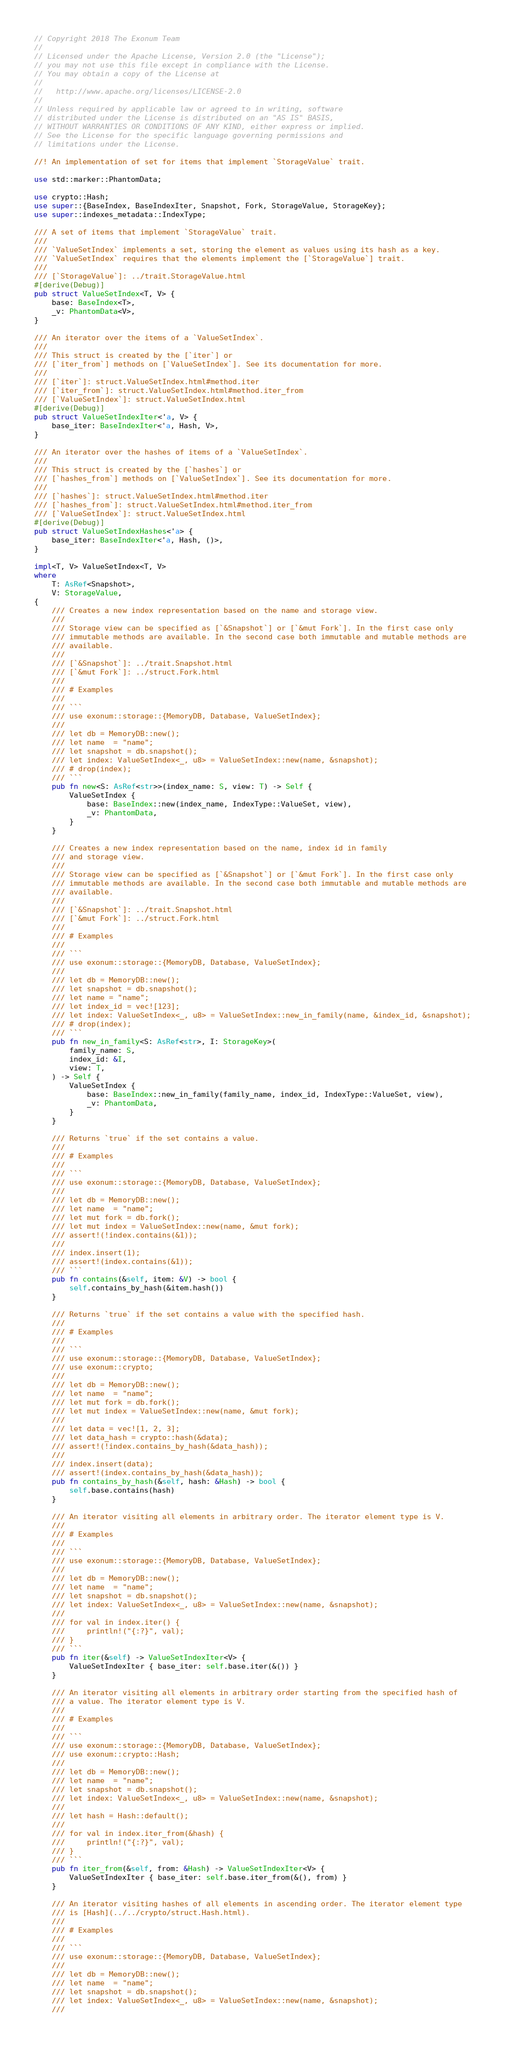<code> <loc_0><loc_0><loc_500><loc_500><_Rust_>// Copyright 2018 The Exonum Team
//
// Licensed under the Apache License, Version 2.0 (the "License");
// you may not use this file except in compliance with the License.
// You may obtain a copy of the License at
//
//   http://www.apache.org/licenses/LICENSE-2.0
//
// Unless required by applicable law or agreed to in writing, software
// distributed under the License is distributed on an "AS IS" BASIS,
// WITHOUT WARRANTIES OR CONDITIONS OF ANY KIND, either express or implied.
// See the License for the specific language governing permissions and
// limitations under the License.

//! An implementation of set for items that implement `StorageValue` trait.

use std::marker::PhantomData;

use crypto::Hash;
use super::{BaseIndex, BaseIndexIter, Snapshot, Fork, StorageValue, StorageKey};
use super::indexes_metadata::IndexType;

/// A set of items that implement `StorageValue` trait.
///
/// `ValueSetIndex` implements a set, storing the element as values using its hash as a key.
/// `ValueSetIndex` requires that the elements implement the [`StorageValue`] trait.
///
/// [`StorageValue`]: ../trait.StorageValue.html
#[derive(Debug)]
pub struct ValueSetIndex<T, V> {
    base: BaseIndex<T>,
    _v: PhantomData<V>,
}

/// An iterator over the items of a `ValueSetIndex`.
///
/// This struct is created by the [`iter`] or
/// [`iter_from`] methods on [`ValueSetIndex`]. See its documentation for more.
///
/// [`iter`]: struct.ValueSetIndex.html#method.iter
/// [`iter_from`]: struct.ValueSetIndex.html#method.iter_from
/// [`ValueSetIndex`]: struct.ValueSetIndex.html
#[derive(Debug)]
pub struct ValueSetIndexIter<'a, V> {
    base_iter: BaseIndexIter<'a, Hash, V>,
}

/// An iterator over the hashes of items of a `ValueSetIndex`.
///
/// This struct is created by the [`hashes`] or
/// [`hashes_from`] methods on [`ValueSetIndex`]. See its documentation for more.
///
/// [`hashes`]: struct.ValueSetIndex.html#method.iter
/// [`hashes_from`]: struct.ValueSetIndex.html#method.iter_from
/// [`ValueSetIndex`]: struct.ValueSetIndex.html
#[derive(Debug)]
pub struct ValueSetIndexHashes<'a> {
    base_iter: BaseIndexIter<'a, Hash, ()>,
}

impl<T, V> ValueSetIndex<T, V>
where
    T: AsRef<Snapshot>,
    V: StorageValue,
{
    /// Creates a new index representation based on the name and storage view.
    ///
    /// Storage view can be specified as [`&Snapshot`] or [`&mut Fork`]. In the first case only
    /// immutable methods are available. In the second case both immutable and mutable methods are
    /// available.
    ///
    /// [`&Snapshot`]: ../trait.Snapshot.html
    /// [`&mut Fork`]: ../struct.Fork.html
    ///
    /// # Examples
    ///
    /// ```
    /// use exonum::storage::{MemoryDB, Database, ValueSetIndex};
    ///
    /// let db = MemoryDB::new();
    /// let name  = "name";
    /// let snapshot = db.snapshot();
    /// let index: ValueSetIndex<_, u8> = ValueSetIndex::new(name, &snapshot);
    /// # drop(index);
    /// ```
    pub fn new<S: AsRef<str>>(index_name: S, view: T) -> Self {
        ValueSetIndex {
            base: BaseIndex::new(index_name, IndexType::ValueSet, view),
            _v: PhantomData,
        }
    }

    /// Creates a new index representation based on the name, index id in family
    /// and storage view.
    ///
    /// Storage view can be specified as [`&Snapshot`] or [`&mut Fork`]. In the first case only
    /// immutable methods are available. In the second case both immutable and mutable methods are
    /// available.
    ///
    /// [`&Snapshot`]: ../trait.Snapshot.html
    /// [`&mut Fork`]: ../struct.Fork.html
    ///
    /// # Examples
    ///
    /// ```
    /// use exonum::storage::{MemoryDB, Database, ValueSetIndex};
    ///
    /// let db = MemoryDB::new();
    /// let snapshot = db.snapshot();
    /// let name = "name";
    /// let index_id = vec![123];
    /// let index: ValueSetIndex<_, u8> = ValueSetIndex::new_in_family(name, &index_id, &snapshot);
    /// # drop(index);
    /// ```
    pub fn new_in_family<S: AsRef<str>, I: StorageKey>(
        family_name: S,
        index_id: &I,
        view: T,
    ) -> Self {
        ValueSetIndex {
            base: BaseIndex::new_in_family(family_name, index_id, IndexType::ValueSet, view),
            _v: PhantomData,
        }
    }

    /// Returns `true` if the set contains a value.
    ///
    /// # Examples
    ///
    /// ```
    /// use exonum::storage::{MemoryDB, Database, ValueSetIndex};
    ///
    /// let db = MemoryDB::new();
    /// let name  = "name";
    /// let mut fork = db.fork();
    /// let mut index = ValueSetIndex::new(name, &mut fork);
    /// assert!(!index.contains(&1));
    ///
    /// index.insert(1);
    /// assert!(index.contains(&1));
    /// ```
    pub fn contains(&self, item: &V) -> bool {
        self.contains_by_hash(&item.hash())
    }

    /// Returns `true` if the set contains a value with the specified hash.
    ///
    /// # Examples
    ///
    /// ```
    /// use exonum::storage::{MemoryDB, Database, ValueSetIndex};
    /// use exonum::crypto;
    ///
    /// let db = MemoryDB::new();
    /// let name  = "name";
    /// let mut fork = db.fork();
    /// let mut index = ValueSetIndex::new(name, &mut fork);
    ///
    /// let data = vec![1, 2, 3];
    /// let data_hash = crypto::hash(&data);
    /// assert!(!index.contains_by_hash(&data_hash));
    ///
    /// index.insert(data);
    /// assert!(index.contains_by_hash(&data_hash));
    pub fn contains_by_hash(&self, hash: &Hash) -> bool {
        self.base.contains(hash)
    }

    /// An iterator visiting all elements in arbitrary order. The iterator element type is V.
    ///
    /// # Examples
    ///
    /// ```
    /// use exonum::storage::{MemoryDB, Database, ValueSetIndex};
    ///
    /// let db = MemoryDB::new();
    /// let name  = "name";
    /// let snapshot = db.snapshot();
    /// let index: ValueSetIndex<_, u8> = ValueSetIndex::new(name, &snapshot);
    ///
    /// for val in index.iter() {
    ///     println!("{:?}", val);
    /// }
    /// ```
    pub fn iter(&self) -> ValueSetIndexIter<V> {
        ValueSetIndexIter { base_iter: self.base.iter(&()) }
    }

    /// An iterator visiting all elements in arbitrary order starting from the specified hash of
    /// a value. The iterator element type is V.
    ///
    /// # Examples
    ///
    /// ```
    /// use exonum::storage::{MemoryDB, Database, ValueSetIndex};
    /// use exonum::crypto::Hash;
    ///
    /// let db = MemoryDB::new();
    /// let name  = "name";
    /// let snapshot = db.snapshot();
    /// let index: ValueSetIndex<_, u8> = ValueSetIndex::new(name, &snapshot);
    ///
    /// let hash = Hash::default();
    ///
    /// for val in index.iter_from(&hash) {
    ///     println!("{:?}", val);
    /// }
    /// ```
    pub fn iter_from(&self, from: &Hash) -> ValueSetIndexIter<V> {
        ValueSetIndexIter { base_iter: self.base.iter_from(&(), from) }
    }

    /// An iterator visiting hashes of all elements in ascending order. The iterator element type
    /// is [Hash](../../crypto/struct.Hash.html).
    ///
    /// # Examples
    ///
    /// ```
    /// use exonum::storage::{MemoryDB, Database, ValueSetIndex};
    ///
    /// let db = MemoryDB::new();
    /// let name  = "name";
    /// let snapshot = db.snapshot();
    /// let index: ValueSetIndex<_, u8> = ValueSetIndex::new(name, &snapshot);
    ///</code> 